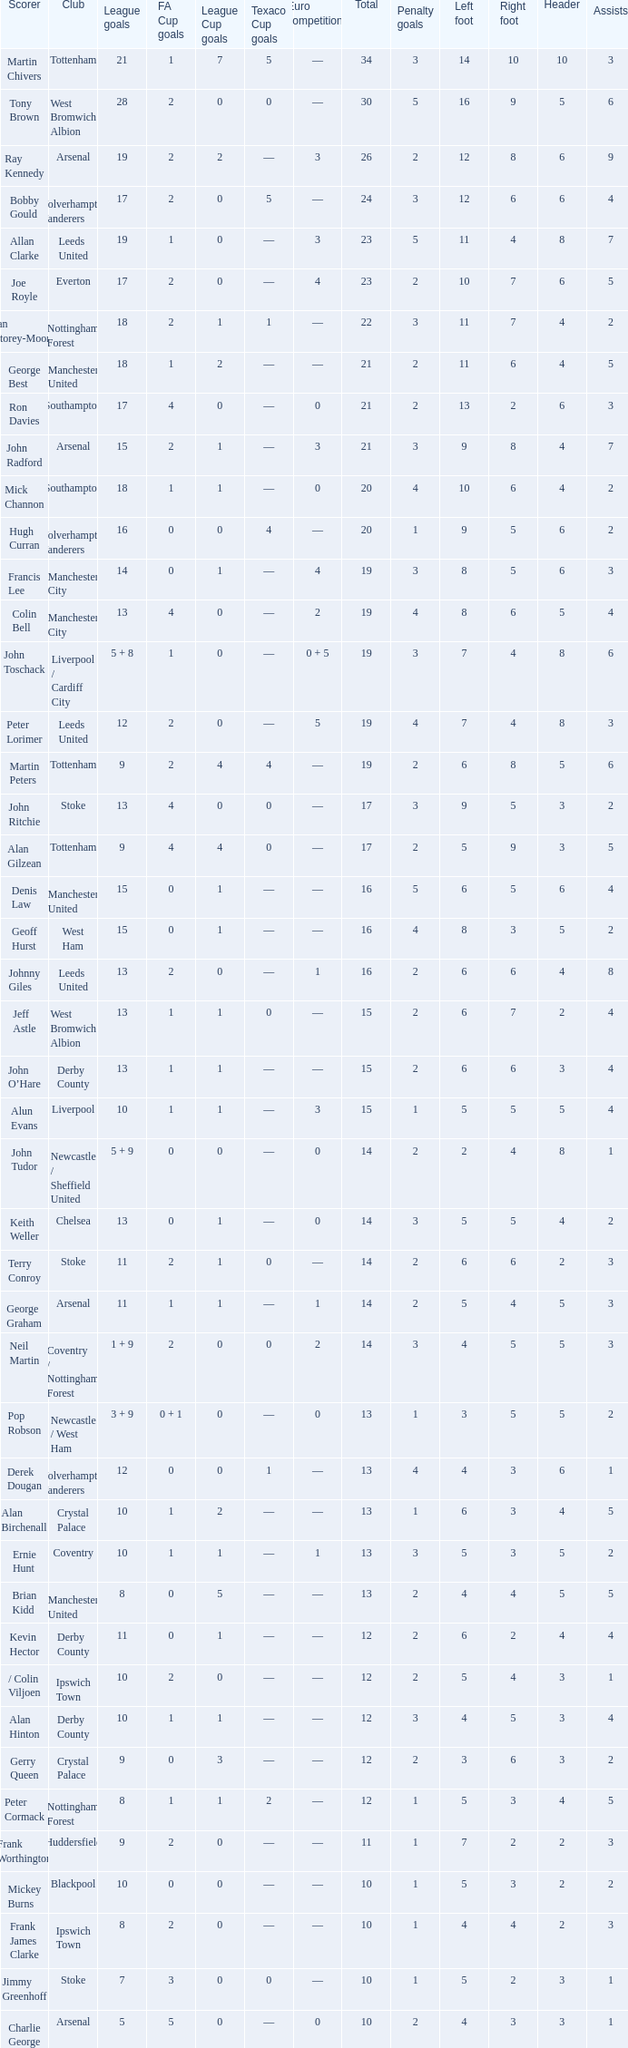What is the lowest League Cup Goals, when Scorer is Denis Law? 1.0. Could you parse the entire table? {'header': ['Scorer', 'Club', 'League goals', 'FA Cup goals', 'League Cup goals', 'Texaco Cup goals', 'Euro competitions', 'Total', 'Penalty goals', 'Left foot', 'Right foot', 'Header', 'Assists '], 'rows': [['Martin Chivers', 'Tottenham', '21', '1', '7', '5', '—', '34', '3', '14', '10', '10', '3'], ['Tony Brown', 'West Bromwich Albion', '28', '2', '0', '0', '—', '30', '5', '16', '9', '5', '6'], ['Ray Kennedy', 'Arsenal', '19', '2', '2', '—', '3', '26', '2', '12', '8', '6', '9'], ['Bobby Gould', 'Wolverhampton Wanderers', '17', '2', '0', '5', '—', '24', '3', '12', '6', '6', '4'], ['Allan Clarke', 'Leeds United', '19', '1', '0', '—', '3', '23', '5', '11', '4', '8', '7'], ['Joe Royle', 'Everton', '17', '2', '0', '—', '4', '23', '2', '10', '7', '6', '5'], ['Ian Storey-Moore', 'Nottingham Forest', '18', '2', '1', '1', '—', '22', '3', '11', '7', '4', '2'], ['George Best', 'Manchester United', '18', '1', '2', '—', '—', '21', '2', '11', '6', '4', '5'], ['Ron Davies', 'Southampton', '17', '4', '0', '—', '0', '21', '2', '13', '2', '6', '3'], ['John Radford', 'Arsenal', '15', '2', '1', '—', '3', '21', '3', '9', '8', '4', '7'], ['Mick Channon', 'Southampton', '18', '1', '1', '—', '0', '20', '4', '10', '6', '4', '2'], ['Hugh Curran', 'Wolverhampton Wanderers', '16', '0', '0', '4', '—', '20', '1', '9', '5', '6', '2'], ['Francis Lee', 'Manchester City', '14', '0', '1', '—', '4', '19', '3', '8', '5', '6', '3'], ['Colin Bell', 'Manchester City', '13', '4', '0', '—', '2', '19', '4', '8', '6', '5', '4'], ['John Toschack', 'Liverpool / Cardiff City', '5 + 8', '1', '0', '—', '0 + 5', '19', '3', '7', '4', '8', '6'], ['Peter Lorimer', 'Leeds United', '12', '2', '0', '—', '5', '19', '4', '7', '4', '8', '3'], ['Martin Peters', 'Tottenham', '9', '2', '4', '4', '—', '19', '2', '6', '8', '5', '6'], ['John Ritchie', 'Stoke', '13', '4', '0', '0', '—', '17', '3', '9', '5', '3', '2'], ['Alan Gilzean', 'Tottenham', '9', '4', '4', '0', '—', '17', '2', '5', '9', '3', '5'], ['Denis Law', 'Manchester United', '15', '0', '1', '—', '—', '16', '5', '6', '5', '6', '4'], ['Geoff Hurst', 'West Ham', '15', '0', '1', '—', '—', '16', '4', '8', '3', '5', '2'], ['Johnny Giles', 'Leeds United', '13', '2', '0', '—', '1', '16', '2', '6', '6', '4', '8'], ['Jeff Astle', 'West Bromwich Albion', '13', '1', '1', '0', '—', '15', '2', '6', '7', '2', '4'], ['John O’Hare', 'Derby County', '13', '1', '1', '—', '—', '15', '2', '6', '6', '3', '4'], ['Alun Evans', 'Liverpool', '10', '1', '1', '—', '3', '15', '1', '5', '5', '5', '4'], ['John Tudor', 'Newcastle / Sheffield United', '5 + 9', '0', '0', '—', '0', '14', '2', '2', '4', '8', '1'], ['Keith Weller', 'Chelsea', '13', '0', '1', '—', '0', '14', '3', '5', '5', '4', '2'], ['Terry Conroy', 'Stoke', '11', '2', '1', '0', '—', '14', '2', '6', '6', '2', '3'], ['George Graham', 'Arsenal', '11', '1', '1', '—', '1', '14', '2', '5', '4', '5', '3'], ['Neil Martin', 'Coventry / Nottingham Forest', '1 + 9', '2', '0', '0', '2', '14', '3', '4', '5', '5', '3'], ['Pop Robson', 'Newcastle / West Ham', '3 + 9', '0 + 1', '0', '—', '0', '13', '1', '3', '5', '5', '2'], ['Derek Dougan', 'Wolverhampton Wanderers', '12', '0', '0', '1', '—', '13', '4', '4', '3', '6', '1'], ['Alan Birchenall', 'Crystal Palace', '10', '1', '2', '—', '—', '13', '1', '6', '3', '4', '5'], ['Ernie Hunt', 'Coventry', '10', '1', '1', '—', '1', '13', '3', '5', '3', '5', '2'], ['Brian Kidd', 'Manchester United', '8', '0', '5', '—', '—', '13', '2', '4', '4', '5', '5'], ['Kevin Hector', 'Derby County', '11', '0', '1', '—', '—', '12', '2', '6', '2', '4', '4'], ['/ Colin Viljoen', 'Ipswich Town', '10', '2', '0', '—', '—', '12', '2', '5', '4', '3', '1'], ['Alan Hinton', 'Derby County', '10', '1', '1', '—', '—', '12', '3', '4', '5', '3', '4'], ['Gerry Queen', 'Crystal Palace', '9', '0', '3', '—', '—', '12', '2', '3', '6', '3', '2'], ['Peter Cormack', 'Nottingham Forest', '8', '1', '1', '2', '—', '12', '1', '5', '3', '4', '5'], ['Frank Worthington', 'Huddersfield', '9', '2', '0', '—', '—', '11', '1', '7', '2', '2', '3'], ['Mickey Burns', 'Blackpool', '10', '0', '0', '—', '—', '10', '1', '5', '3', '2', '2'], ['Frank James Clarke', 'Ipswich Town', '8', '2', '0', '—', '—', '10', '1', '4', '4', '2', '3'], ['Jimmy Greenhoff', 'Stoke', '7', '3', '0', '0', '—', '10', '1', '5', '2', '3', '1'], ['Charlie George', 'Arsenal', '5', '5', '0', '—', '0', '10', '2', '4', '3', '3', '1']]} 